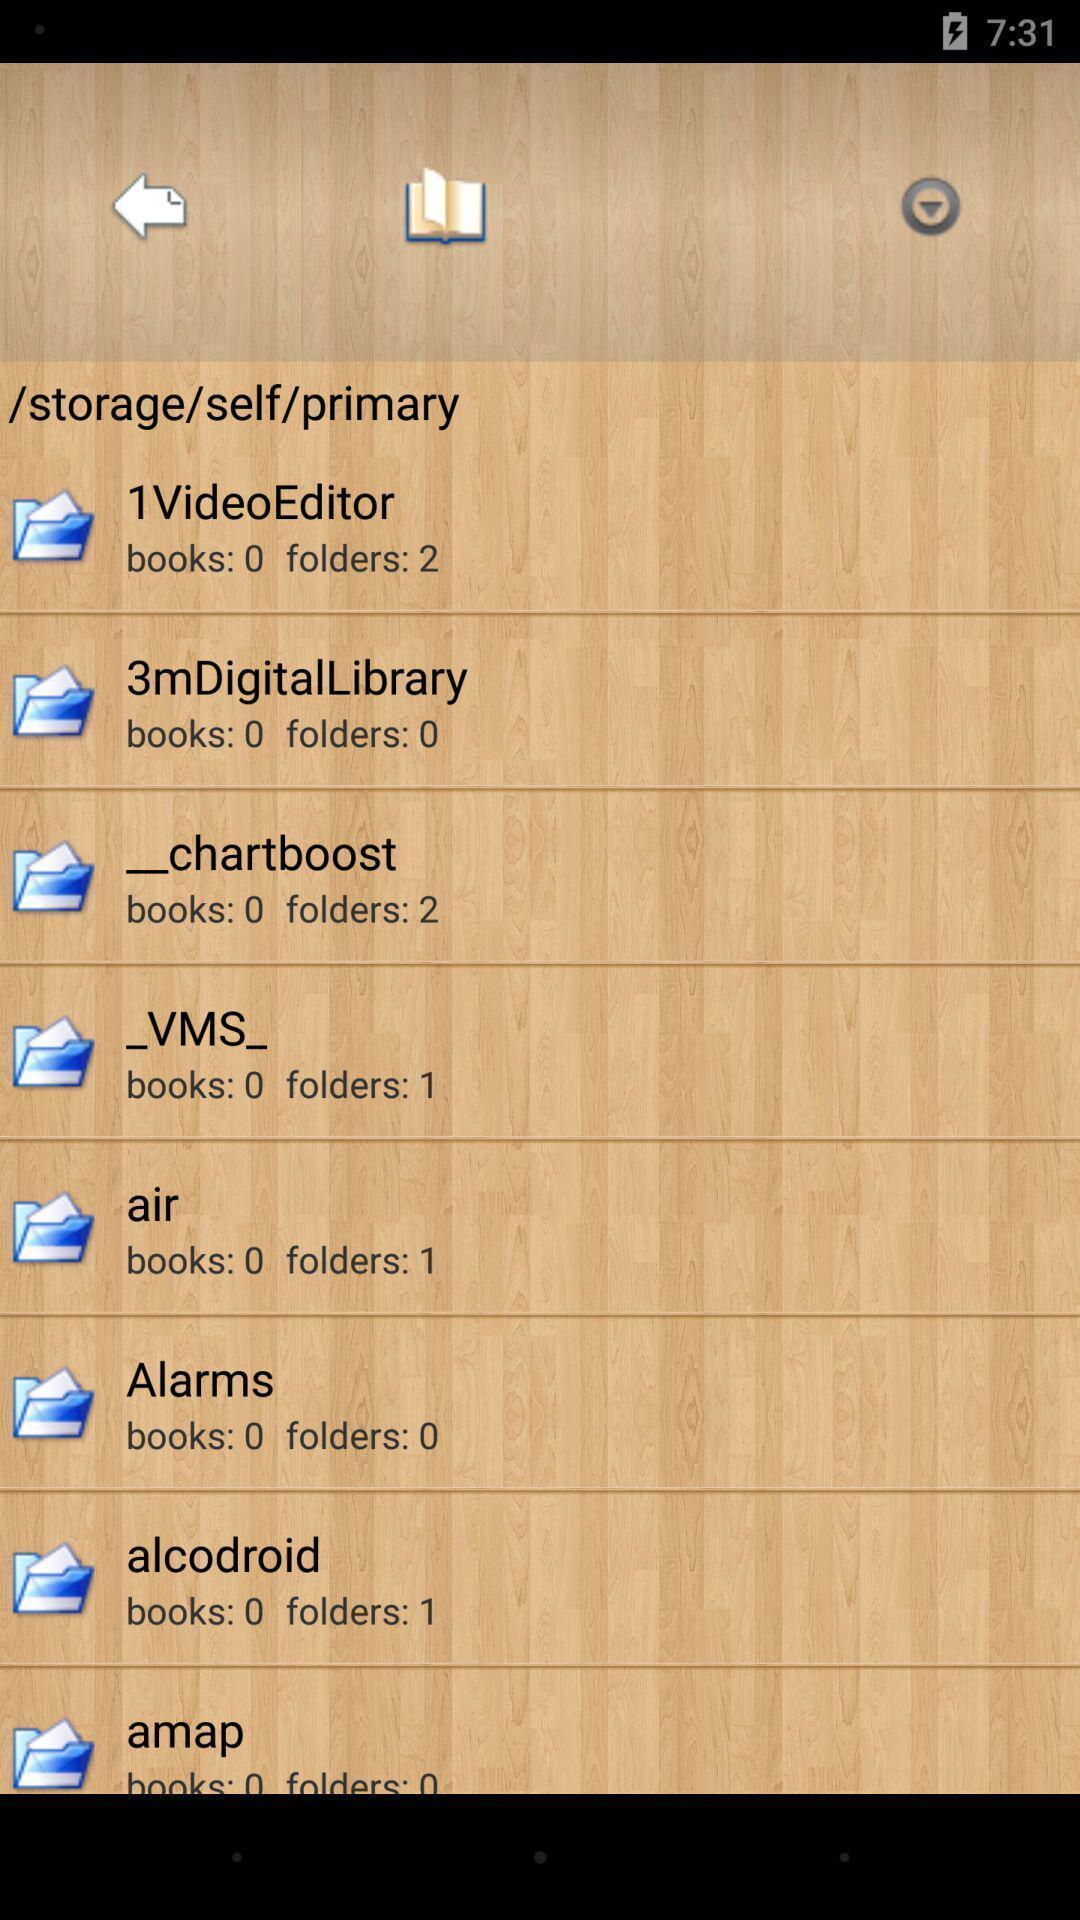What can you discern from this picture? Screen shows different folders in a file. 